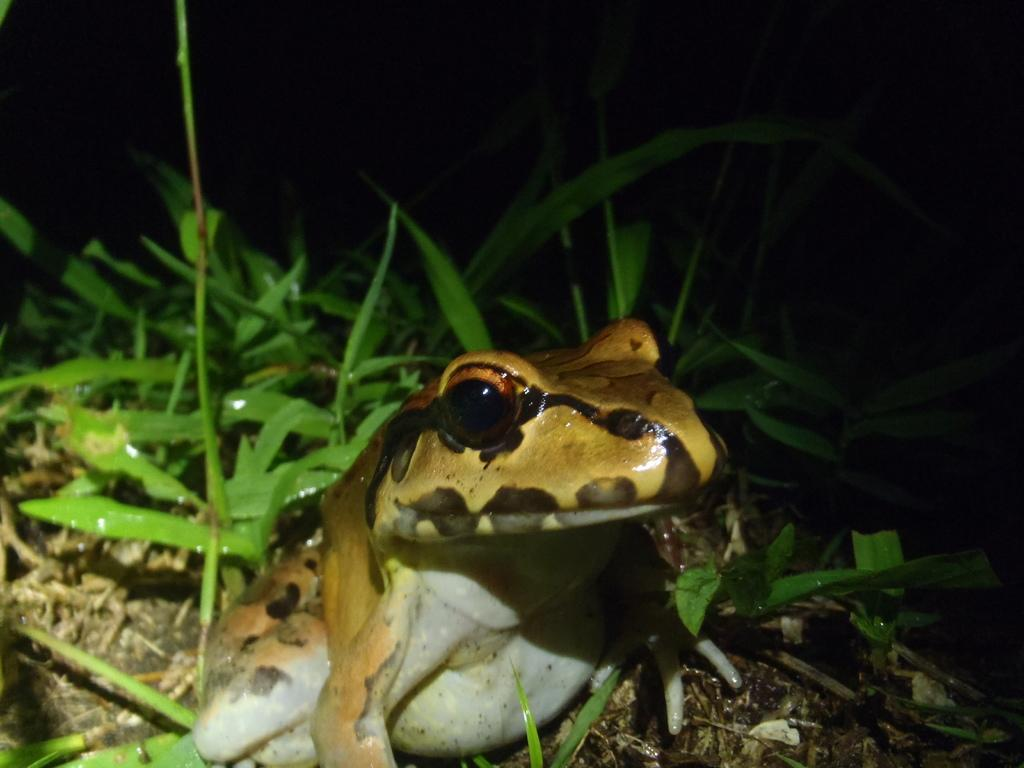What type of animal is in the image? There is a frog in the image. What colors can be seen on the frog? The frog has brown and white colors. What color is the grass in the image? The grass in the image is green. What color is the background of the image? The background of the image is black. What type of bomb can be seen in the image? There is no bomb present in the image; it features a frog on green grass with a black background. 